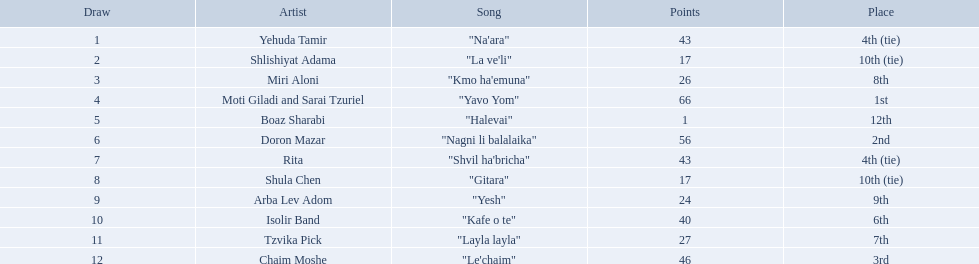Who were all the artists at the contest? Yehuda Tamir, Shlishiyat Adama, Miri Aloni, Moti Giladi and Sarai Tzuriel, Boaz Sharabi, Doron Mazar, Rita, Shula Chen, Arba Lev Adom, Isolir Band, Tzvika Pick, Chaim Moshe. What were their point totals? 43, 17, 26, 66, 1, 56, 43, 17, 24, 40, 27, 46. Of these, which is the least amount of points? 1. Which artists received this point total? Boaz Sharabi. What are the points? 43, 17, 26, 66, 1, 56, 43, 17, 24, 40, 27, 46. What is the least? 1. Which artist has that much Boaz Sharabi. What is the spot of the participant who gained just 1 point? 12th. What is the appellation of the artist stated in the foregoing question? Boaz Sharabi. What are the marks? 43, 17, 26, 66, 1, 56, 43, 17, 24, 40, 27, 46. What is the lowest? 1. Which artist has that quantity? Boaz Sharabi. What are the tallies in the competition? 43, 17, 26, 66, 1, 56, 43, 17, 24, 40, 27, 46. What is the least tally? 1. What artist achieved these tallies? Boaz Sharabi. What are the marks in the contest? 43, 17, 26, 66, 1, 56, 43, 17, 24, 40, 27, 46. What is the lowest mark? 1. Which artist was awarded these marks? Boaz Sharabi. What is the count of artists? Yehuda Tamir, Shlishiyat Adama, Miri Aloni, Moti Giladi and Sarai Tzuriel, Boaz Sharabi, Doron Mazar, Rita, Shula Chen, Arba Lev Adom, Isolir Band, Tzvika Pick, Chaim Moshe. What are the fewest points awarded? 1. Which artist was granted those points? Boaz Sharabi. What are the numbers? 43, 17, 26, 66, 1, 56, 43, 17, 24, 40, 27, 46. What is the smallest? 1. Which artist owns that total? Boaz Sharabi. What rank did the contestant who got only one point occupy? 12th. Parse the table in full. {'header': ['Draw', 'Artist', 'Song', 'Points', 'Place'], 'rows': [['1', 'Yehuda Tamir', '"Na\'ara"', '43', '4th (tie)'], ['2', 'Shlishiyat Adama', '"La ve\'li"', '17', '10th (tie)'], ['3', 'Miri Aloni', '"Kmo ha\'emuna"', '26', '8th'], ['4', 'Moti Giladi and Sarai Tzuriel', '"Yavo Yom"', '66', '1st'], ['5', 'Boaz Sharabi', '"Halevai"', '1', '12th'], ['6', 'Doron Mazar', '"Nagni li balalaika"', '56', '2nd'], ['7', 'Rita', '"Shvil ha\'bricha"', '43', '4th (tie)'], ['8', 'Shula Chen', '"Gitara"', '17', '10th (tie)'], ['9', 'Arba Lev Adom', '"Yesh"', '24', '9th'], ['10', 'Isolir Band', '"Kafe o te"', '40', '6th'], ['11', 'Tzvika Pick', '"Layla layla"', '27', '7th'], ['12', 'Chaim Moshe', '"Le\'chaim"', '46', '3rd']]} What is the artist's name referred to in the prior question? Boaz Sharabi. Can you name all the artists involved? Yehuda Tamir, Shlishiyat Adama, Miri Aloni, Moti Giladi and Sarai Tzuriel, Boaz Sharabi, Doron Mazar, Rita, Shula Chen, Arba Lev Adom, Isolir Band, Tzvika Pick, Chaim Moshe. What was the point tally for each of them? 43, 17, 26, 66, 1, 56, 43, 17, 24, 40, 27, 46. And who among them had the lowest score? Boaz Sharabi. 